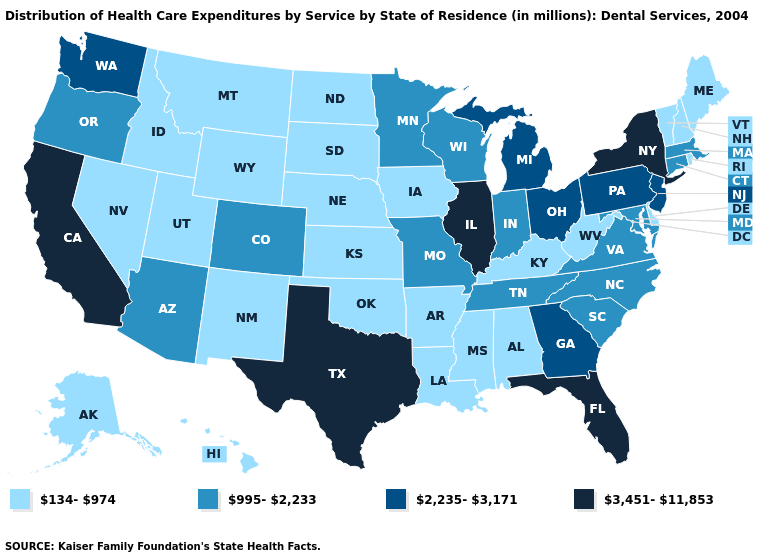How many symbols are there in the legend?
Short answer required. 4. Among the states that border Massachusetts , which have the lowest value?
Answer briefly. New Hampshire, Rhode Island, Vermont. Does the map have missing data?
Answer briefly. No. Does New York have the highest value in the Northeast?
Give a very brief answer. Yes. Is the legend a continuous bar?
Write a very short answer. No. Name the states that have a value in the range 3,451-11,853?
Answer briefly. California, Florida, Illinois, New York, Texas. What is the value of Indiana?
Concise answer only. 995-2,233. What is the value of North Carolina?
Answer briefly. 995-2,233. Does Delaware have the lowest value in the USA?
Keep it brief. Yes. What is the highest value in the USA?
Quick response, please. 3,451-11,853. Is the legend a continuous bar?
Write a very short answer. No. What is the value of South Carolina?
Write a very short answer. 995-2,233. Which states have the lowest value in the MidWest?
Concise answer only. Iowa, Kansas, Nebraska, North Dakota, South Dakota. What is the value of Missouri?
Quick response, please. 995-2,233. 